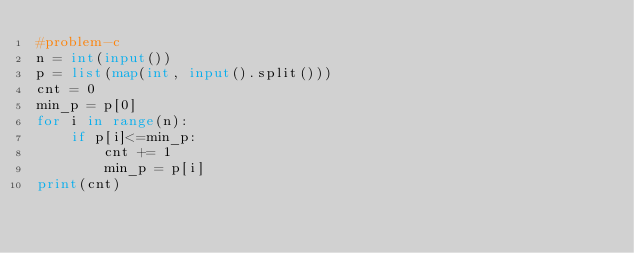Convert code to text. <code><loc_0><loc_0><loc_500><loc_500><_Python_>#problem-c
n = int(input())
p = list(map(int, input().split()))
cnt = 0
min_p = p[0]
for i in range(n):
    if p[i]<=min_p:
        cnt += 1
        min_p = p[i]
print(cnt)
</code> 